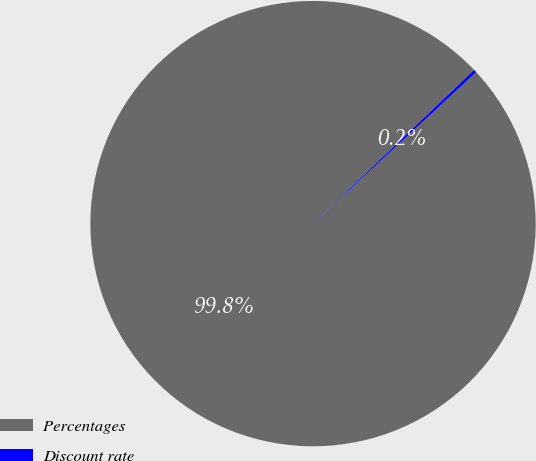<chart> <loc_0><loc_0><loc_500><loc_500><pie_chart><fcel>Percentages<fcel>Discount rate<nl><fcel>99.78%<fcel>0.22%<nl></chart> 